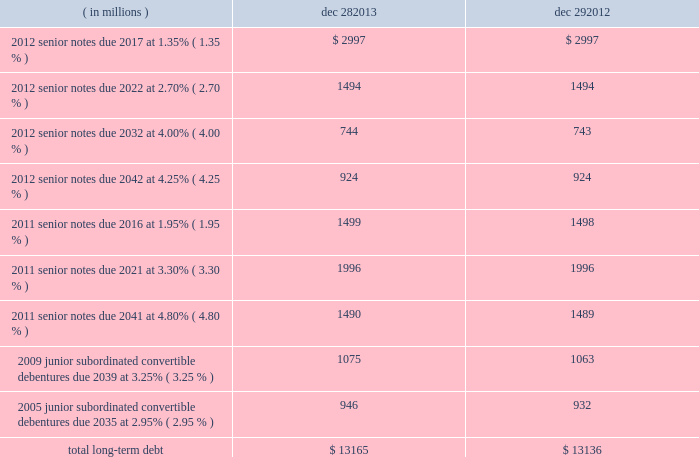Note 15 : chipset design issue in january 2011 , as part of our ongoing quality assurance procedures , we identified a design issue with the intel ae 6 series express chipset family .
The issue affected chipsets sold in the fourth quarter of 2010 and january 2011 .
We subsequently implemented a silicon fix and began shipping the updated version of the affected chipset in february 2011 .
The total cost in 2011 to repair and replace affected materials and systems , located with customers and in the market , was $ 422 million .
We do not expect to have any significant future adjustments related to this issue .
Note 16 : borrowings short-term debt as of december 28 , 2013 , short-term debt consisted of drafts payable of $ 257 million and notes payable of $ 24 million ( drafts payable of $ 264 million and notes payable of $ 48 million as of december 29 , 2012 ) .
We have an ongoing authorization from our board of directors to borrow up to $ 3.0 billion , including through the issuance of commercial paper .
Maximum borrowings under our commercial paper program during 2013 were $ 300 million ( $ 500 million during 2012 ) .
Our commercial paper was rated a-1+ by standard & poor 2019s and p-1 by moody 2019s as of december 28 , 2013 .
Long-term debt our long-term debt at the end of each period was as follows : ( in millions ) dec 28 , dec 29 .
Senior notes in the fourth quarter of 2012 , we issued $ 6.2 billion aggregate principal amount of senior unsecured notes for general corporate purposes and to repurchase shares of our common stock pursuant to our authorized common stock repurchase program .
In the third quarter of 2011 , we issued $ 5.0 billion aggregate principal amount of senior unsecured notes , primarily to repurchase shares of our common stock pursuant to our authorized common stock repurchase program , and for general corporate purposes .
Our senior notes pay a fixed rate of interest semiannually .
We may redeem our senior notes , in whole or in part , at any time at our option at specified redemption prices .
The senior notes rank equally in right of payment with all of our other existing and future senior unsecured indebtedness and will effectively rank junior to all liabilities of our subsidiaries .
Table of contents intel corporation notes to consolidated financial statements ( continued ) .
What is the net cash flow from long-term debt during 2013? 
Computations: (13165 - 13136)
Answer: 29.0. 